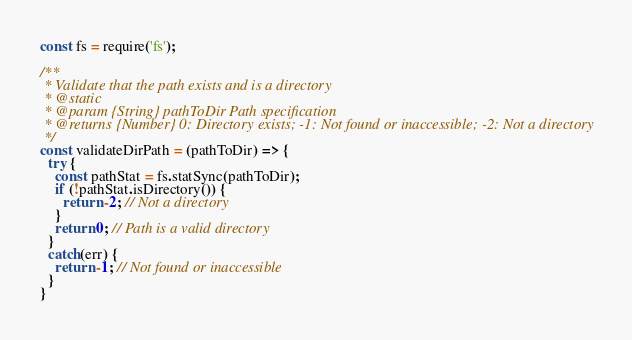<code> <loc_0><loc_0><loc_500><loc_500><_JavaScript_>const fs = require('fs');

/**
 * Validate that the path exists and is a directory
 * @static
 * @param {String} pathToDir Path specification
 * @returns {Number} 0: Directory exists; -1: Not found or inaccessible; -2: Not a directory
 */
const validateDirPath = (pathToDir) => {
  try {
    const pathStat = fs.statSync(pathToDir);
    if (!pathStat.isDirectory()) {
      return -2; // Not a directory
    }
    return 0; // Path is a valid directory
  }
  catch(err) {
    return -1; // Not found or inaccessible
  }
}</code> 